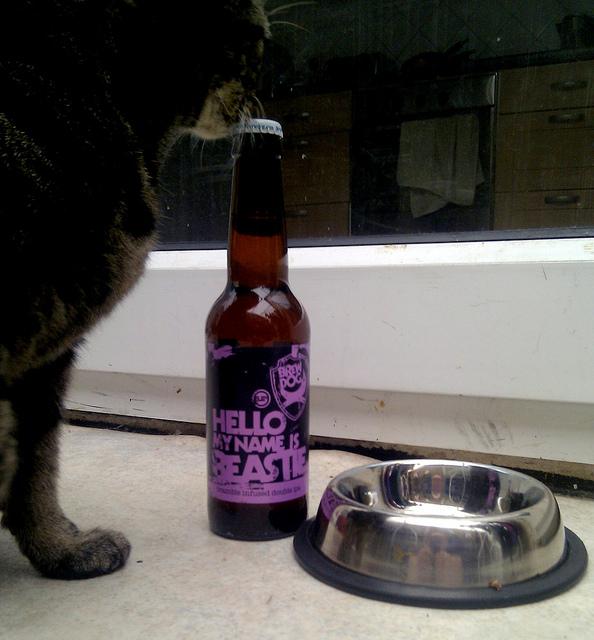What language is seen?
Short answer required. English. Is the bottle empty?
Be succinct. No. What beverage is in the bottle?
Keep it brief. Beer. What would have to happen first before the cat could drink that water?
Be succinct. Fill up bowl. What brand of beer is this?
Quick response, please. Beastie. Are there any baby animals in this photo?
Give a very brief answer. No. What is standing next to the bottle?
Short answer required. Cat. What company makes this beer?
Quick response, please. Brewdog. 